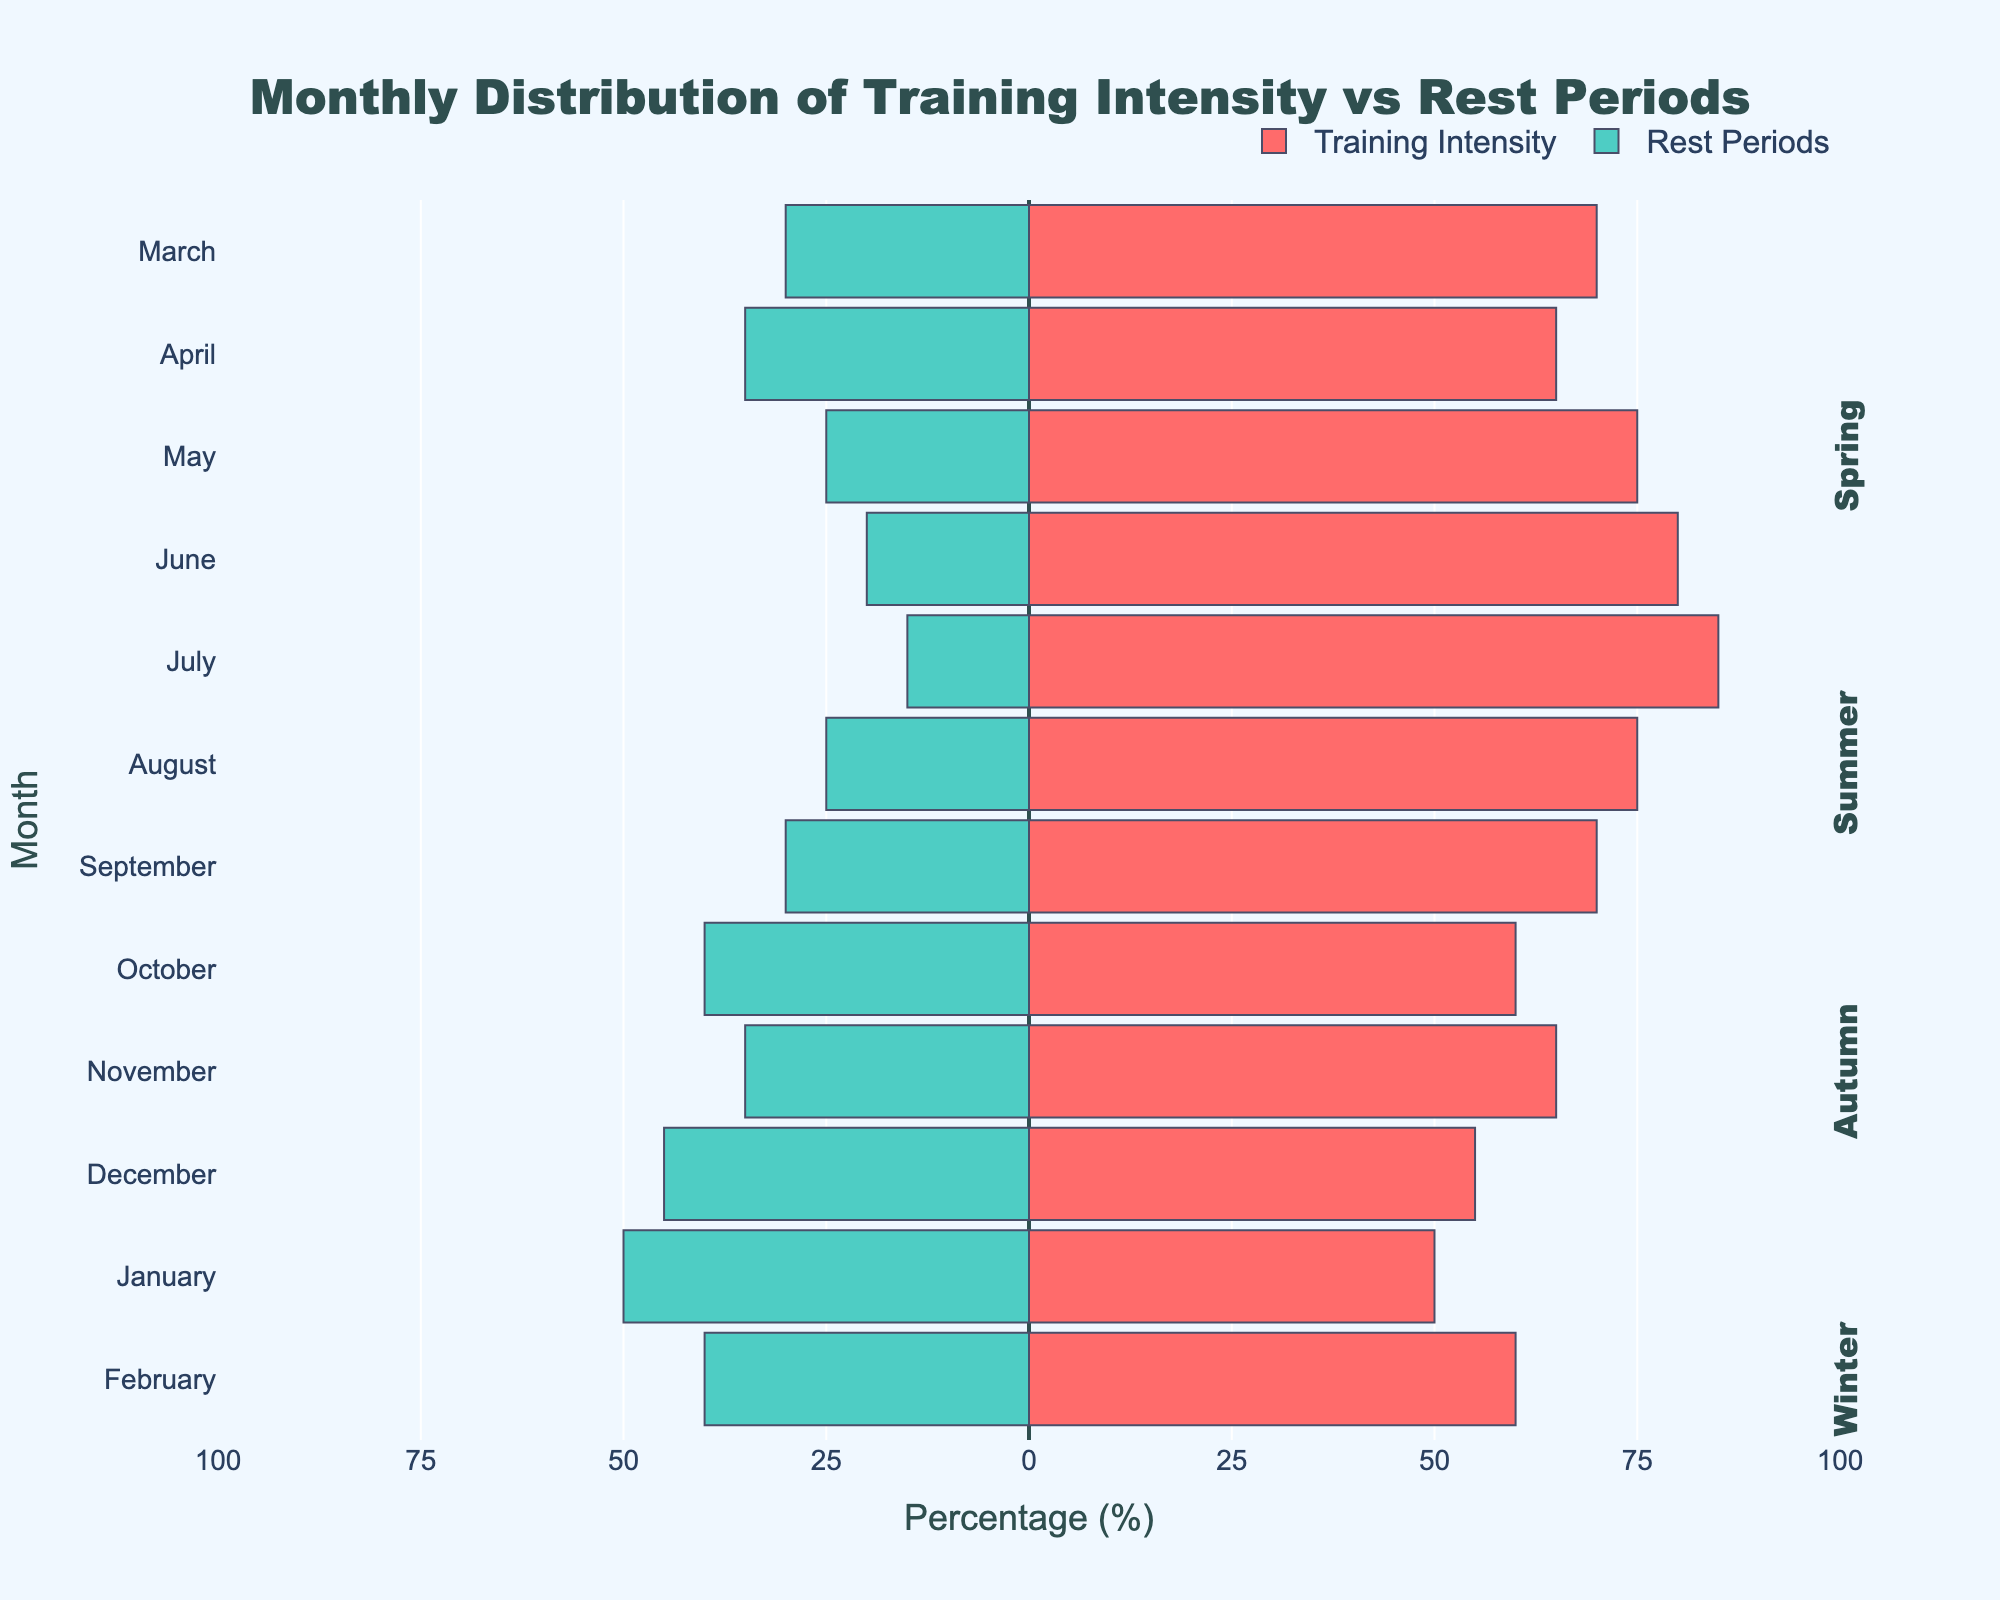What is the month with the highest training intensity in Winter? Observe the Training Intensity bars for December, January, and February. The highest bar (closest to the right) is February with 60%.
Answer: February In which month is the difference between Training Intensity and Rest Periods the highest? Calculate the absolute difference between Training Intensity and Rest Periods for each month. The largest difference is in July (85% - 15% = 70%).
Answer: July Which season has the most balanced distribution between Training Intensity and Rest Periods? Find the months with the closest percentages between Training Intensity and Rest Periods. January (50% Training and 50% Rest) is the most balanced, which is in Winter.
Answer: Winter What is the average rest period percentage for Summer? Sum the Rest Periods percentages for June, July, and August and then divide by 3: (20% + 15% + 25%) / 3 = 20%.
Answer: 20% Compare Training Intensity in Spring and Autumn. Which season has a higher average? Calculate the average Training Intensity for each season: Spring (70% + 65% + 75%) / 3 = 70%, Autumn (70% + 60% + 65%) / 3 = 65%. Spring has a higher average.
Answer: Spring Which month has the lowest training intensity overall? Look for the bar with the smallest length (closest to the left) in the Training Intensity set. January, with 50%, has the lowest overall Training Intensity.
Answer: January What is the total Training Intensity percentage for Spring? Sum the Training Intensity percentages for March, April, and May: 70% + 65% + 75% = 210%.
Answer: 210% Identify the month with the least rest period in Summer. Examine Rest Period bars for June, July, and August. The shortest bar (closest to the left) is July, which has a 15% Rest Period.
Answer: July 